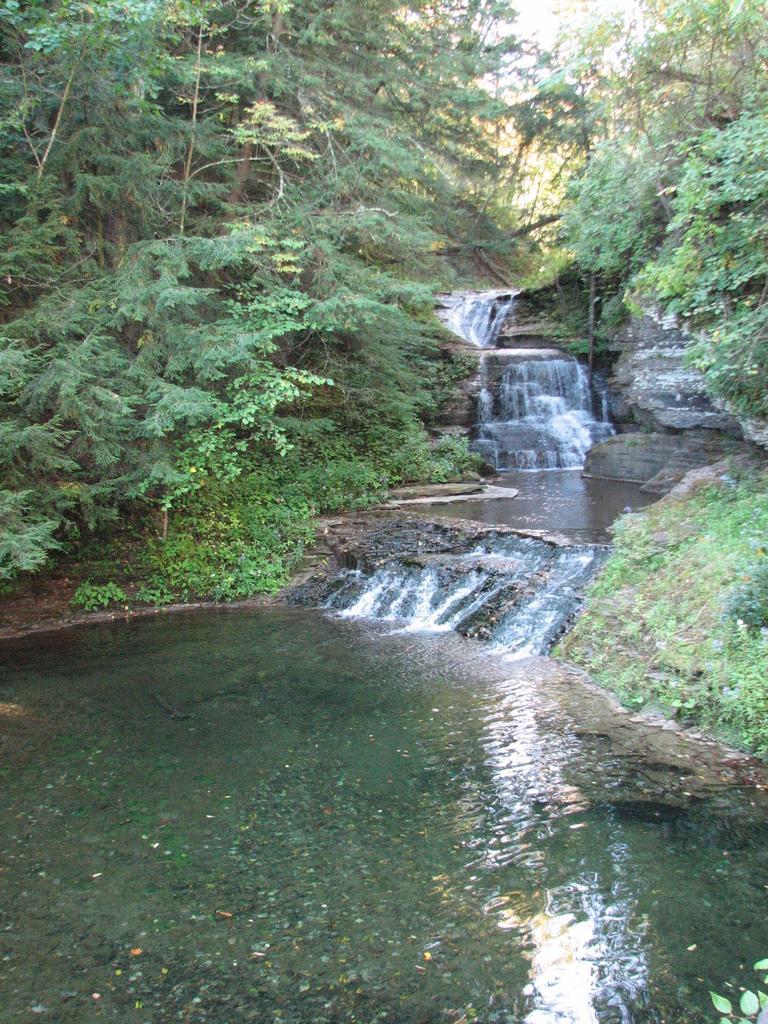Please provide a concise description of this image. In this picture we can see water, few rocks and trees. 